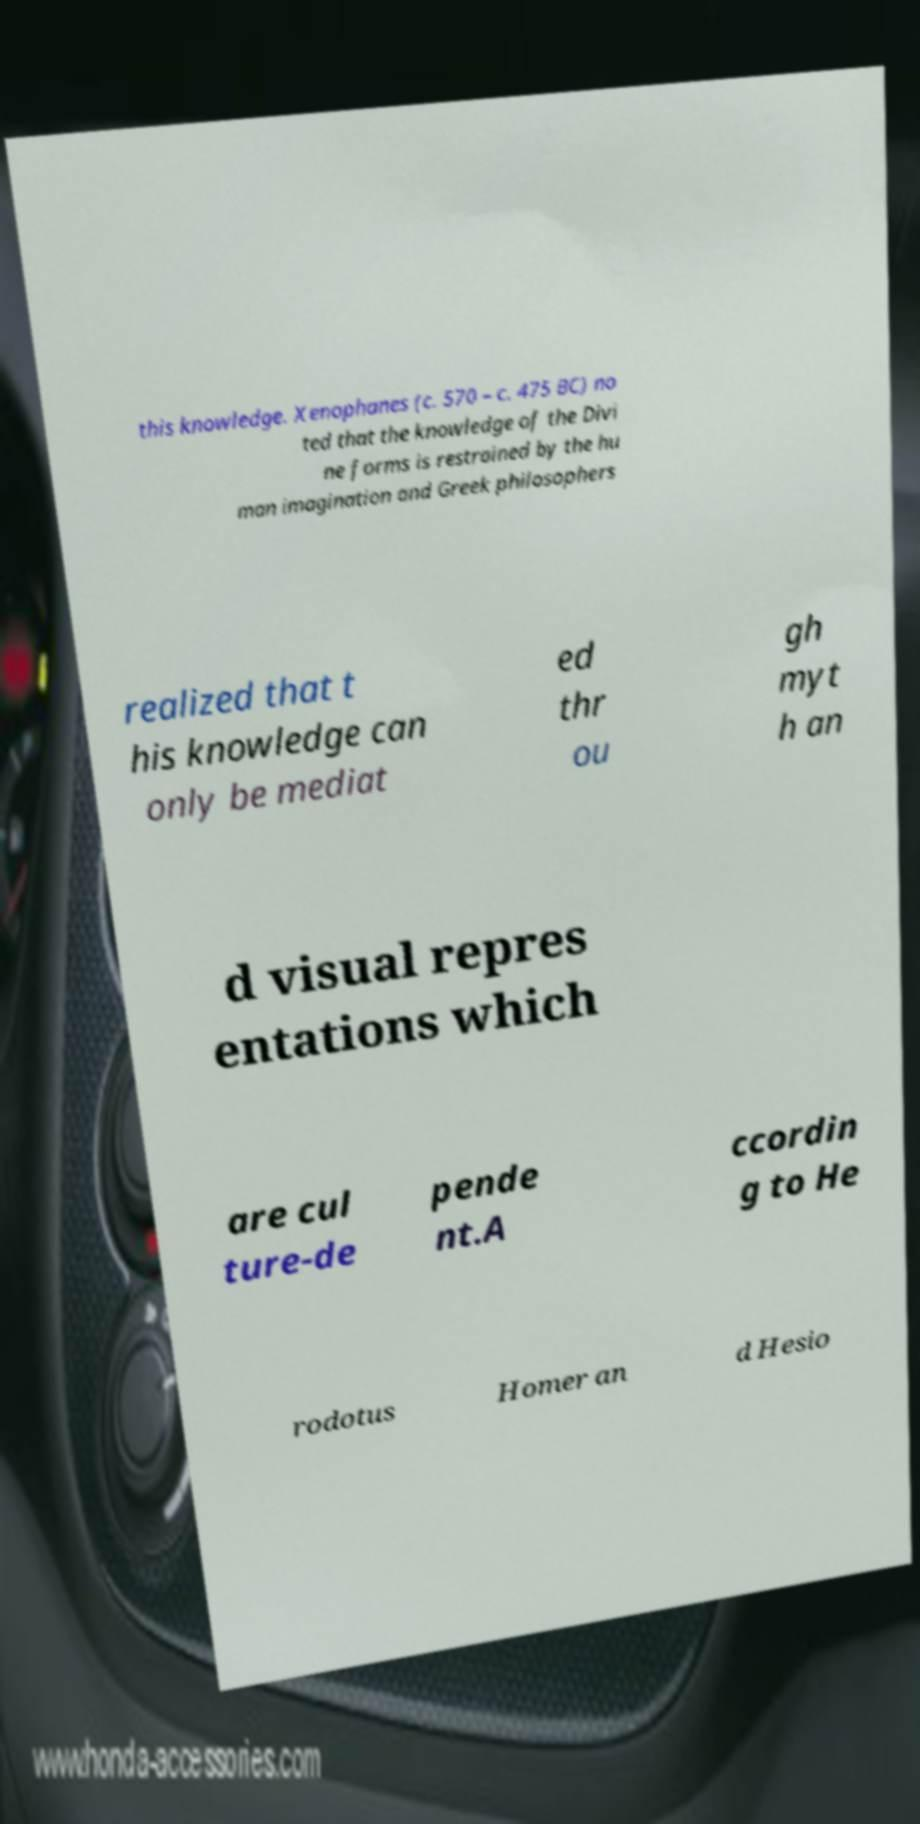What messages or text are displayed in this image? I need them in a readable, typed format. this knowledge. Xenophanes (c. 570 – c. 475 BC) no ted that the knowledge of the Divi ne forms is restrained by the hu man imagination and Greek philosophers realized that t his knowledge can only be mediat ed thr ou gh myt h an d visual repres entations which are cul ture-de pende nt.A ccordin g to He rodotus Homer an d Hesio 